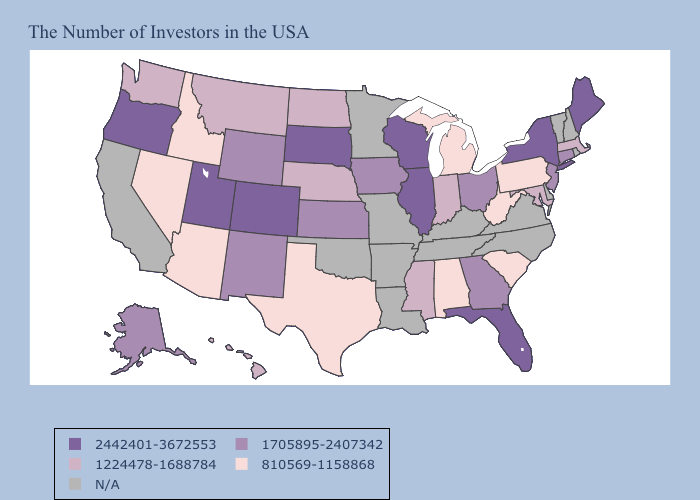Which states have the lowest value in the Northeast?
Be succinct. Pennsylvania. Which states have the lowest value in the Northeast?
Write a very short answer. Pennsylvania. Name the states that have a value in the range 1224478-1688784?
Answer briefly. Massachusetts, Maryland, Indiana, Mississippi, Nebraska, North Dakota, Montana, Washington, Hawaii. Does Texas have the lowest value in the South?
Keep it brief. Yes. Name the states that have a value in the range 1705895-2407342?
Concise answer only. Connecticut, New Jersey, Ohio, Georgia, Iowa, Kansas, Wyoming, New Mexico, Alaska. Which states have the lowest value in the USA?
Give a very brief answer. Pennsylvania, South Carolina, West Virginia, Michigan, Alabama, Texas, Arizona, Idaho, Nevada. Name the states that have a value in the range 2442401-3672553?
Answer briefly. Maine, New York, Florida, Wisconsin, Illinois, South Dakota, Colorado, Utah, Oregon. How many symbols are there in the legend?
Write a very short answer. 5. Which states have the lowest value in the West?
Short answer required. Arizona, Idaho, Nevada. Does Texas have the lowest value in the USA?
Be succinct. Yes. Name the states that have a value in the range 2442401-3672553?
Be succinct. Maine, New York, Florida, Wisconsin, Illinois, South Dakota, Colorado, Utah, Oregon. Name the states that have a value in the range 2442401-3672553?
Keep it brief. Maine, New York, Florida, Wisconsin, Illinois, South Dakota, Colorado, Utah, Oregon. Name the states that have a value in the range N/A?
Answer briefly. Rhode Island, New Hampshire, Vermont, Delaware, Virginia, North Carolina, Kentucky, Tennessee, Louisiana, Missouri, Arkansas, Minnesota, Oklahoma, California. What is the lowest value in the MidWest?
Write a very short answer. 810569-1158868. 